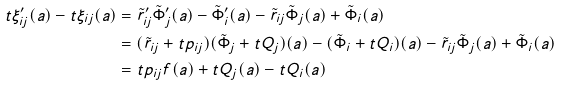<formula> <loc_0><loc_0><loc_500><loc_500>t \xi _ { i j } ^ { \prime } ( a ) - t \xi _ { i j } ( a ) & = \tilde { r } _ { i j } ^ { \prime } \tilde { \Phi } _ { j } ^ { \prime } ( a ) - \tilde { \Phi } _ { i } ^ { \prime } ( a ) - \tilde { r } _ { i j } \tilde { \Phi } _ { j } ( a ) + \tilde { \Phi } _ { i } ( a ) \\ & = ( \tilde { r } _ { i j } + t p _ { i j } ) ( \tilde { \Phi } _ { j } + t Q _ { j } ) ( a ) - ( \tilde { \Phi } _ { i } + t Q _ { i } ) ( a ) - \tilde { r } _ { i j } \tilde { \Phi } _ { j } ( a ) + \tilde { \Phi } _ { i } ( a ) \\ & = t p _ { i j } f ( a ) + t Q _ { j } ( a ) - t Q _ { i } ( a )</formula> 